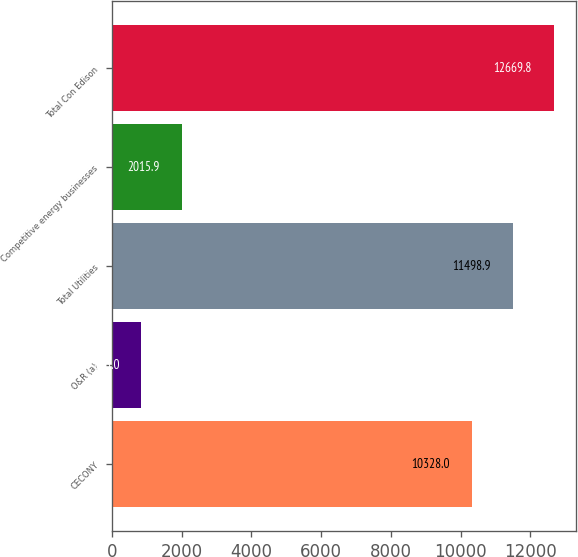Convert chart to OTSL. <chart><loc_0><loc_0><loc_500><loc_500><bar_chart><fcel>CECONY<fcel>O&R (a)<fcel>Total Utilities<fcel>Competitive energy businesses<fcel>Total Con Edison<nl><fcel>10328<fcel>845<fcel>11498.9<fcel>2015.9<fcel>12669.8<nl></chart> 